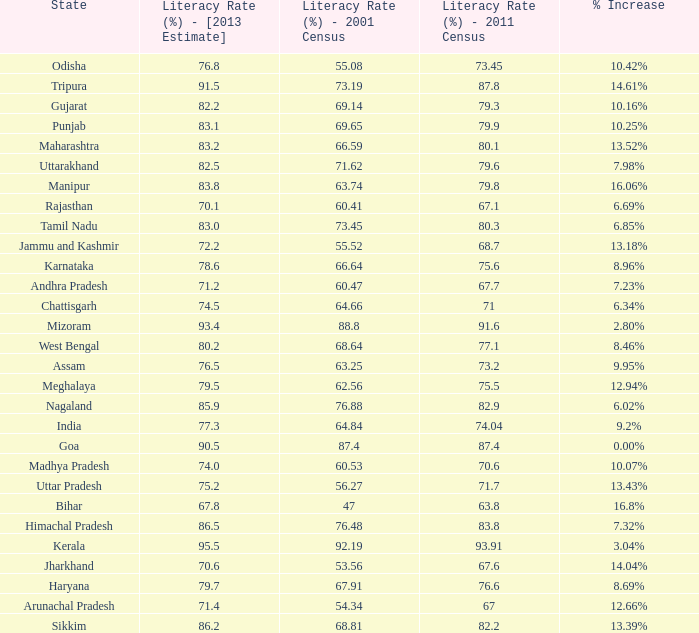What is the average estimated 2013 literacy rate for the states that had a literacy rate of 68.81% in the 2001 census and a literacy rate higher than 79.6% in the 2011 census? 86.2. 